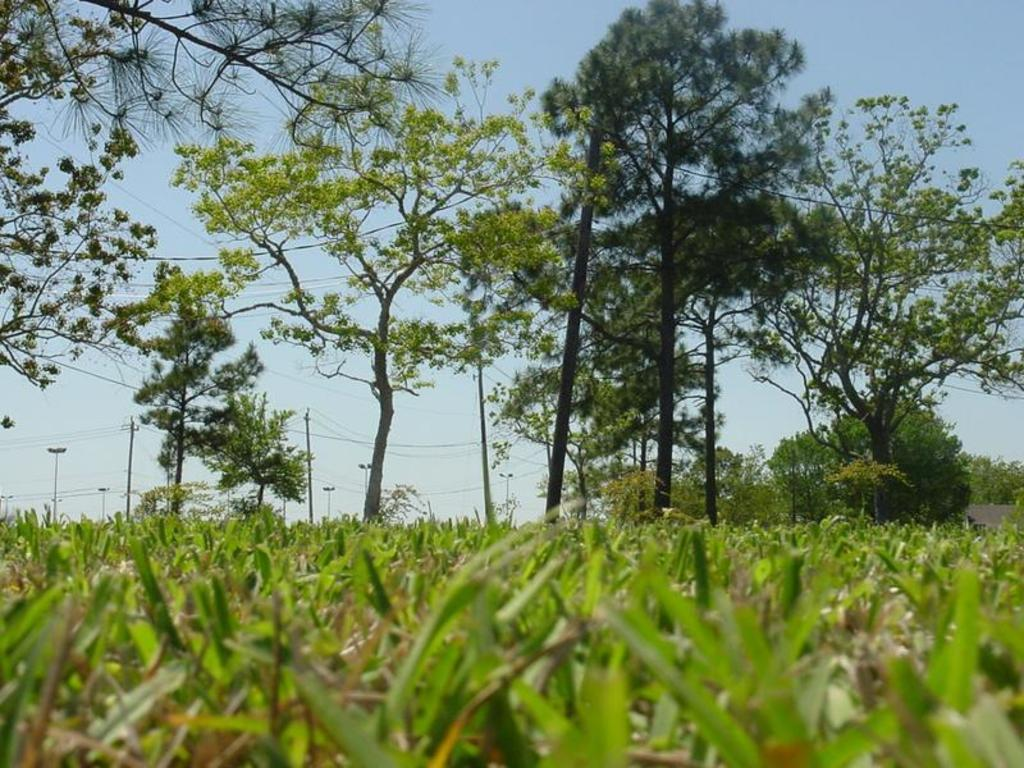What type of animals can be seen in the image? There is cattle in the image. What type of vegetation is present in the image? There are trees in the image. What structures can be seen in the image? There are electric poles in the image. What else can be seen in the image related to the electric poles? There are wires in the image. What committee is responsible for maintaining the station in the image? There is no committee or station present in the image; it features cattle, trees, electric poles, and wires. 